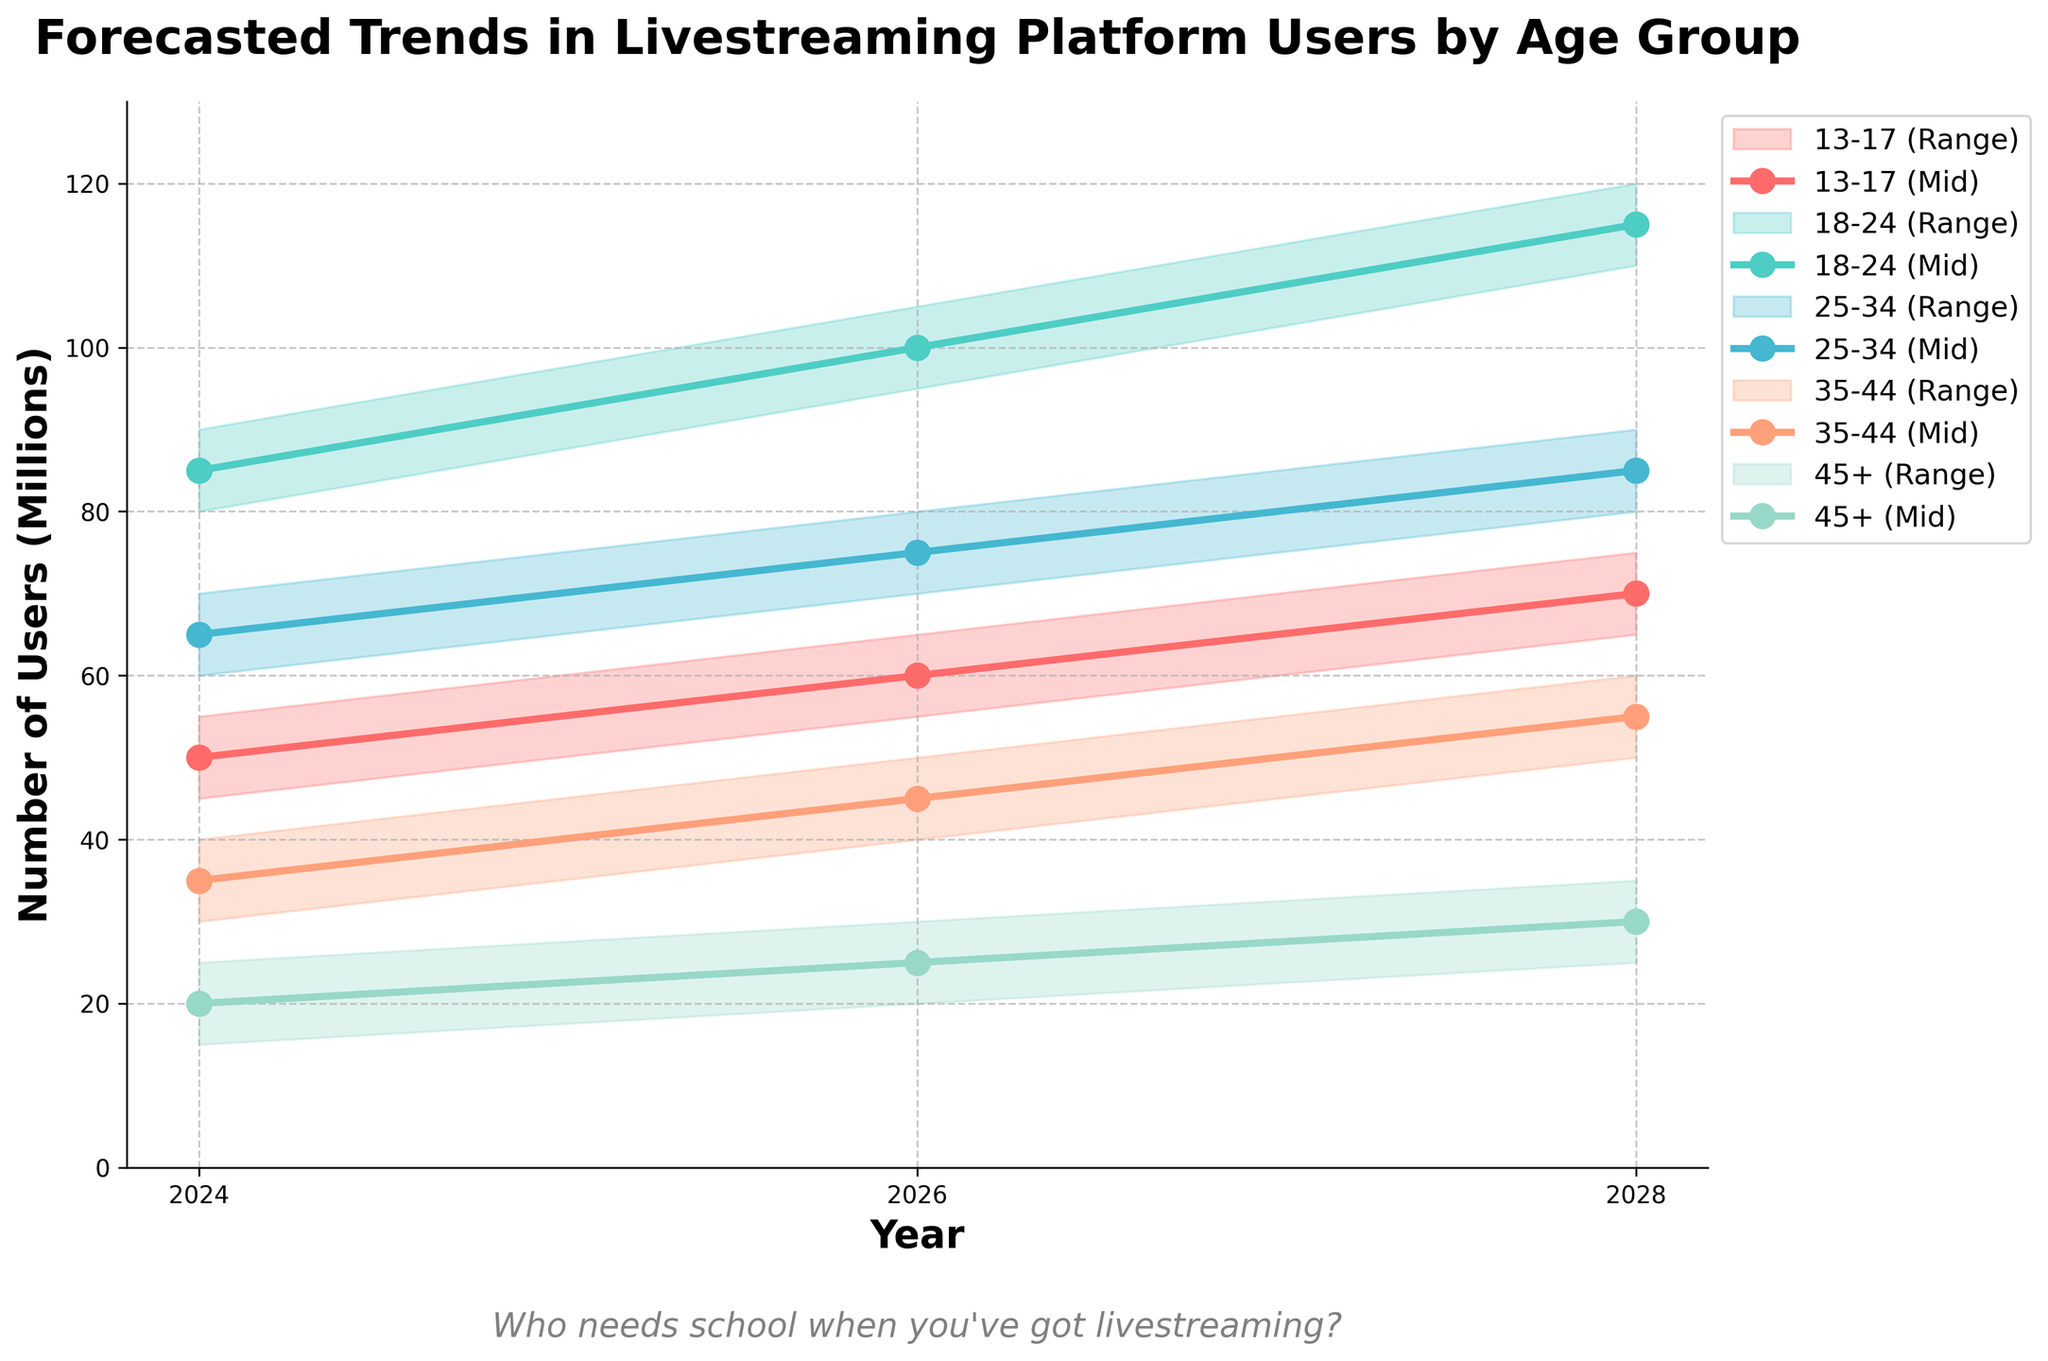What is the range of user estimates for the age group 18-24 in the year 2026? The range of user estimates for the age group 18-24 in year 2026 can be identified by looking at the low and high estimates for that year. In 2026, the low estimate is 95 million and the high estimate is 105 million. Thus, the range is 105 - 95 = 10 million.
Answer: 10 million How many age groups have a mid estimate of users between 50 and 70 million in 2024? In 2024, we examine the mid estimates for each age group: 50 for 13-17, 85 for 18-24, 65 for 25-34, 35 for 35-44, and 20 for 45+. Only two age groups (13-17 and 25-34) fall within the range of 50 to 70 million.
Answer: 2 Which age group shows the highest mid estimate of users in 2028? By checking the mid estimates for each age group in 2028, which are 70 for 13-17, 115 for 18-24, 85 for 25-34, 55 for 35-44, and 30 for 45+, we find that the age group 18-24 has the highest mid estimate at 115 million.
Answer: 18-24 What is the total mid estimate of users for all age groups combined in the year 2024? Sum the mid estimates for all age groups in 2024: 50 (13-17) + 85 (18-24) + 65 (25-34) + 35 (35-44) + 20 (45+) = 255 million.
Answer: 255 million Which age group has the least variation in user estimates in 2028? To find the age group with the least variation in 2028, we look at the difference between the high and low estimates: 
13-17: 75-65 = 10
18-24: 120-110 = 10
25-34: 90-80 = 10
35-44: 60-50 = 10
45+: 35-25 = 10
All age groups have the same variation of 10 million.
Answer: All ages Between which two age groups is the growth in mid estimate from 2024 to 2028 the highest? Calculate the difference in mid estimates for each age group from 2024 to 2028:
13-17: 70 - 50 = 20
18-24: 115 - 85 = 30
25-34: 85 - 65 = 20
35-44: 55 - 35 = 20
45+: 30 - 20 = 10
The highest growth is in the age group 18-24 with a 30 million increase.
Answer: 18-24 What is the combined range of low estimates for the age groups 35-44 and 45+ in 2026? For 35-44, the low estimate in 2026 is 40 and for 45+ it is 20. Adding these together gives 40 + 20 = 60 million.
Answer: 60 million What average number of users would you estimate for the 13-17 age group in 2026, considering both the mid estimate and its range? The mid estimate is 60, with a range of 60-55 = 5 (low) to 65-60 = 5 (high). Averaging the low, mid, and high estimates: (55 + 60 + 65)/3 = 60 million.
Answer: 60 million How does the growth trend of users aged 45+ compare from 2024 to 2028 with those aged 18-24 in terms of percentage? For 45+: 
(30 - 20)/20 * 100 = 50%
For 18-24: 
(115 - 85)/85 * 100 = 35.29%
The 45+ age group shows a higher growth percentage.
Answer: 45+ higher In what year does the 25-34 age group have the same mid estimate as the 13-17 age group in 2028? Check mid estimates for 25-34 against the mid estimate of 13-17 in 2028 (70). The 25-34 group has a mid estimate of 65 in 2024, 75 in 2026, and 85 in 2028. Thus, there is no year where they match the mid estimate of 70 in 2028 for 13-17.
Answer: None 